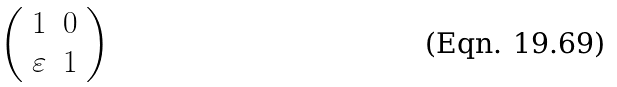<formula> <loc_0><loc_0><loc_500><loc_500>\left ( \begin{array} [ c ] { c c } 1 & 0 \\ \varepsilon & 1 \end{array} \right )</formula> 